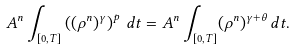<formula> <loc_0><loc_0><loc_500><loc_500>A ^ { n } \int _ { [ 0 , T ] } \left ( ( \rho ^ { n } ) ^ { \gamma } \right ) ^ { p } \, d t = A ^ { n } \int _ { [ 0 , T ] } ( \rho ^ { n } ) ^ { \gamma + \theta } \, d t .</formula> 